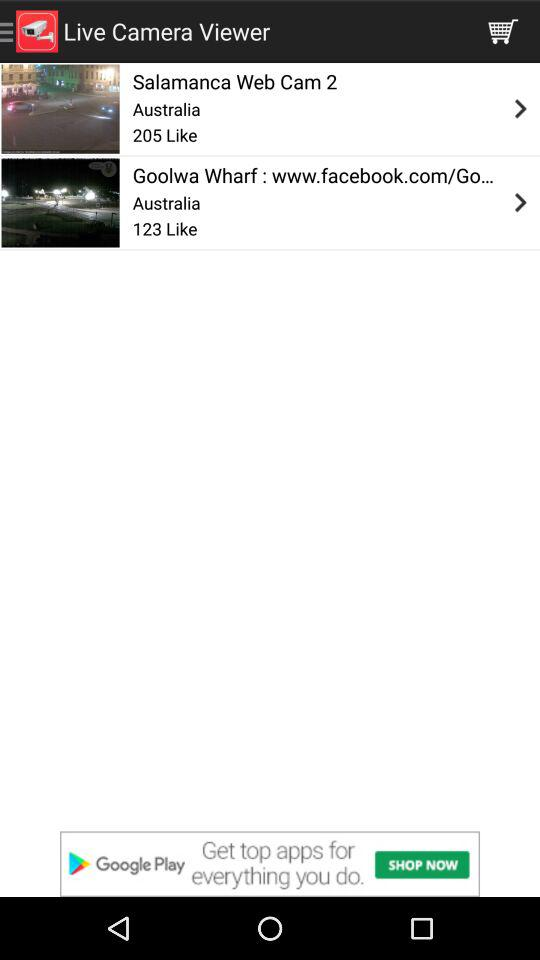What is the Goolwa Wharf's Facebook ID?
When the provided information is insufficient, respond with <no answer>. <no answer> 